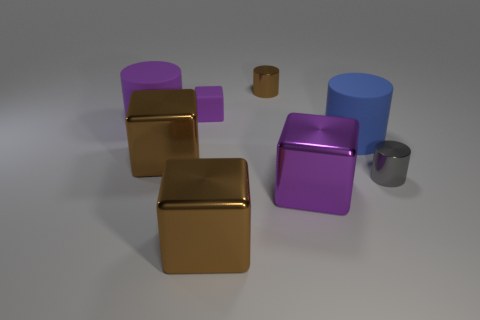Do the brown cylinder and the large cylinder that is left of the large blue thing have the same material?
Provide a succinct answer. No. How many other things are the same shape as the small purple thing?
Your response must be concise. 3. There is a rubber block; is it the same color as the small object that is to the right of the small brown metal object?
Give a very brief answer. No. What is the shape of the purple rubber object right of the big cylinder on the left side of the purple metal block?
Ensure brevity in your answer.  Cube. What size is the other block that is the same color as the small block?
Your answer should be compact. Large. There is a large purple object that is in front of the big purple rubber object; does it have the same shape as the small matte object?
Ensure brevity in your answer.  Yes. Are there more big purple things in front of the blue cylinder than large purple cylinders in front of the gray cylinder?
Your answer should be very brief. Yes. What number of large metallic blocks are behind the big rubber object that is on the left side of the tiny brown metal object?
Provide a short and direct response. 0. There is a large cylinder that is the same color as the tiny rubber thing; what is it made of?
Your answer should be very brief. Rubber. What number of other objects are the same color as the rubber block?
Your answer should be compact. 2. 